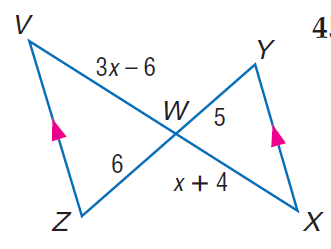Answer the mathemtical geometry problem and directly provide the correct option letter.
Question: Find V W.
Choices: A: 10 B: 12 C: 14 D: 16 B 